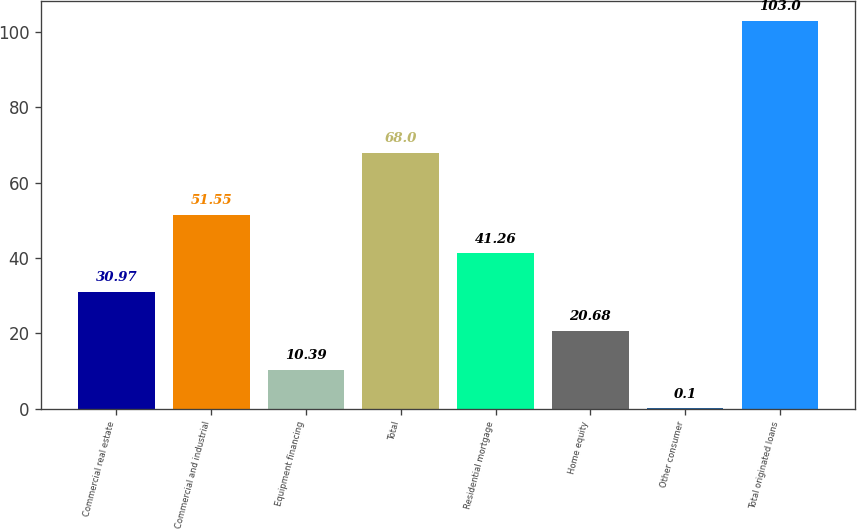<chart> <loc_0><loc_0><loc_500><loc_500><bar_chart><fcel>Commercial real estate<fcel>Commercial and industrial<fcel>Equipment financing<fcel>Total<fcel>Residential mortgage<fcel>Home equity<fcel>Other consumer<fcel>Total originated loans<nl><fcel>30.97<fcel>51.55<fcel>10.39<fcel>68<fcel>41.26<fcel>20.68<fcel>0.1<fcel>103<nl></chart> 